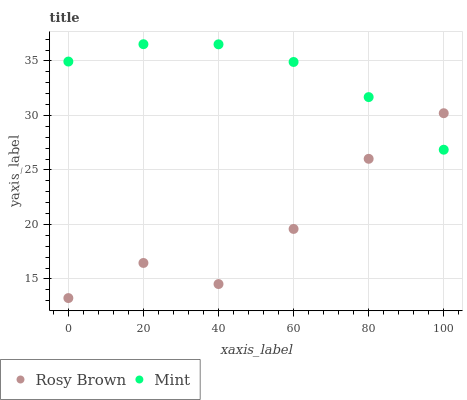Does Rosy Brown have the minimum area under the curve?
Answer yes or no. Yes. Does Mint have the maximum area under the curve?
Answer yes or no. Yes. Does Mint have the minimum area under the curve?
Answer yes or no. No. Is Mint the smoothest?
Answer yes or no. Yes. Is Rosy Brown the roughest?
Answer yes or no. Yes. Is Mint the roughest?
Answer yes or no. No. Does Rosy Brown have the lowest value?
Answer yes or no. Yes. Does Mint have the lowest value?
Answer yes or no. No. Does Mint have the highest value?
Answer yes or no. Yes. Does Mint intersect Rosy Brown?
Answer yes or no. Yes. Is Mint less than Rosy Brown?
Answer yes or no. No. Is Mint greater than Rosy Brown?
Answer yes or no. No. 